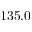<formula> <loc_0><loc_0><loc_500><loc_500>1 3 5 . 0</formula> 